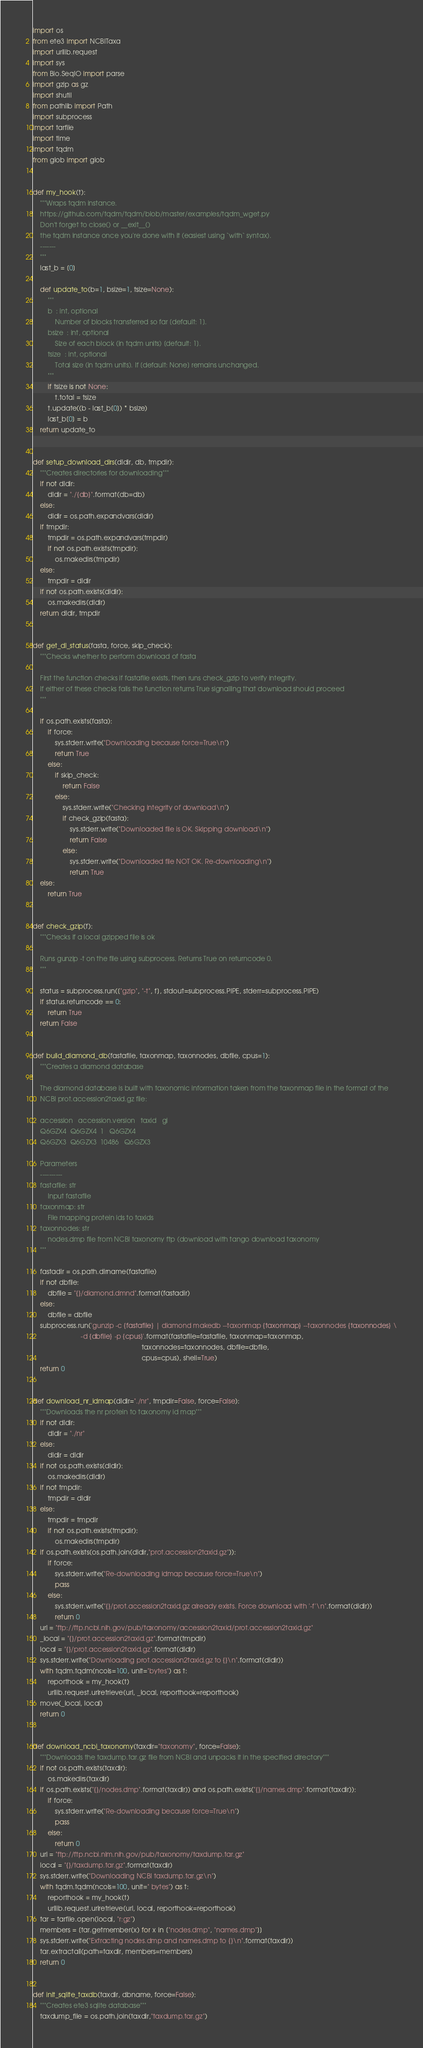<code> <loc_0><loc_0><loc_500><loc_500><_Python_>import os
from ete3 import NCBITaxa
import urllib.request
import sys
from Bio.SeqIO import parse
import gzip as gz
import shutil
from pathlib import Path
import subprocess
import tarfile
import time
import tqdm
from glob import glob


def my_hook(t):
    """Wraps tqdm instance.
    https://github.com/tqdm/tqdm/blob/master/examples/tqdm_wget.py
    Don't forget to close() or __exit__()
    the tqdm instance once you're done with it (easiest using `with` syntax).
    -------
    """
    last_b = [0]

    def update_to(b=1, bsize=1, tsize=None):
        """
        b  : int, optional
            Number of blocks transferred so far [default: 1].
        bsize  : int, optional
            Size of each block (in tqdm units) [default: 1].
        tsize  : int, optional
            Total size (in tqdm units). If [default: None] remains unchanged.
        """
        if tsize is not None:
            t.total = tsize
        t.update((b - last_b[0]) * bsize)
        last_b[0] = b
    return update_to


def setup_download_dirs(dldir, db, tmpdir):
    """Creates directories for downloading"""
    if not dldir:
        dldir = "./{db}".format(db=db)
    else:
        dldir = os.path.expandvars(dldir)
    if tmpdir:
        tmpdir = os.path.expandvars(tmpdir)
        if not os.path.exists(tmpdir):
            os.makedirs(tmpdir)
    else:
        tmpdir = dldir
    if not os.path.exists(dldir):
        os.makedirs(dldir)
    return dldir, tmpdir


def get_dl_status(fasta, force, skip_check):
    """Checks whether to perform download of fasta

    First the function checks if fastafile exists, then runs check_gzip to verify integrity.
    If either of these checks fails the function returns True signalling that download should proceed
    """

    if os.path.exists(fasta):
        if force:
            sys.stderr.write("Downloading because force=True\n")
            return True
        else:
            if skip_check:
                return False
            else:
                sys.stderr.write("Checking integrity of download\n")
                if check_gzip(fasta):
                    sys.stderr.write("Downloaded file is OK. Skipping download\n")
                    return False
                else:
                    sys.stderr.write("Downloaded file NOT OK. Re-downloading\n")
                    return True
    else:
        return True


def check_gzip(f):
    """Checks if a local gzipped file is ok

    Runs gunzip -t on the file using subprocess. Returns True on returncode 0.
    """

    status = subprocess.run(["gzip", "-t", f], stdout=subprocess.PIPE, stderr=subprocess.PIPE)
    if status.returncode == 0:
        return True
    return False


def build_diamond_db(fastafile, taxonmap, taxonnodes, dbfile, cpus=1):
    """Creates a diamond database

    The diamond database is built with taxonomic information taken from the taxonmap file in the format of the
    NCBI prot.accession2taxid.gz file:

    accession	accession.version	taxid	gi
    Q6GZX4	Q6GZX4	1	Q6GZX4
    Q6GZX3	Q6GZX3	10486	Q6GZX3

    Parameters
    ----------
    fastafile: str
        Input fastafile
    taxonmap: str
        File mapping protein ids to taxids
    taxonnodes: str
        nodes.dmp file from NCBI taxonomy ftp (download with tango download taxonomy
    """

    fastadir = os.path.dirname(fastafile)
    if not dbfile:
        dbfile = "{}/diamond.dmnd".format(fastadir)
    else:
        dbfile = dbfile
    subprocess.run('gunzip -c {fastafile} | diamond makedb --taxonmap {taxonmap} --taxonnodes {taxonnodes} \
                          -d {dbfile} -p {cpus}'.format(fastafile=fastafile, taxonmap=taxonmap,
                                                           taxonnodes=taxonnodes, dbfile=dbfile,
                                                           cpus=cpus), shell=True)
    return 0


def download_nr_idmap(dldir="./nr", tmpdir=False, force=False):
    """Downloads the nr protein to taxonomy id map"""
    if not dldir:
        dldir = "./nr"
    else:
        dldir = dldir
    if not os.path.exists(dldir):
        os.makedirs(dldir)
    if not tmpdir:
        tmpdir = dldir
    else:
        tmpdir = tmpdir
        if not os.path.exists(tmpdir):
            os.makedirs(tmpdir)
    if os.path.exists(os.path.join(dldir,"prot.accession2taxid.gz")):
        if force:
            sys.stderr.write("Re-downloading idmap because force=True\n")
            pass
        else:
            sys.stderr.write("{}/prot.accession2taxid.gz already exists. Force download with '-f'\n".format(dldir))
            return 0
    url = "ftp://ftp.ncbi.nih.gov/pub/taxonomy/accession2taxid/prot.accession2taxid.gz"
    _local = "{}/prot.accession2taxid.gz".format(tmpdir)
    local = "{}/prot.accession2taxid.gz".format(dldir)
    sys.stderr.write("Downloading prot.accession2taxid.gz to {}\n".format(dldir))
    with tqdm.tqdm(ncols=100, unit="bytes") as t:
        reporthook = my_hook(t)
        urllib.request.urlretrieve(url, _local, reporthook=reporthook)
    move(_local, local)
    return 0


def download_ncbi_taxonomy(taxdir="taxonomy", force=False):
    """Downloads the taxdump.tar.gz file from NCBI and unpacks it in the specified directory"""
    if not os.path.exists(taxdir):
        os.makedirs(taxdir)
    if os.path.exists("{}/nodes.dmp".format(taxdir)) and os.path.exists("{}/names.dmp".format(taxdir)):
        if force:
            sys.stderr.write("Re-downloading because force=True\n")
            pass
        else:
            return 0
    url = "ftp://ftp.ncbi.nlm.nih.gov/pub/taxonomy/taxdump.tar.gz"
    local = "{}/taxdump.tar.gz".format(taxdir)
    sys.stderr.write("Downloading NCBI taxdump.tar.gz\n")
    with tqdm.tqdm(ncols=100, unit=" bytes") as t:
        reporthook = my_hook(t)
        urllib.request.urlretrieve(url, local, reporthook=reporthook)
    tar = tarfile.open(local, "r:gz")
    members = [tar.getmember(x) for x in ["nodes.dmp", "names.dmp"]]
    sys.stderr.write("Extracting nodes.dmp and names.dmp to {}\n".format(taxdir))
    tar.extractall(path=taxdir, members=members)
    return 0


def init_sqlite_taxdb(taxdir, dbname, force=False):
    """Creates ete3 sqlite database"""
    taxdump_file = os.path.join(taxdir,"taxdump.tar.gz")</code> 